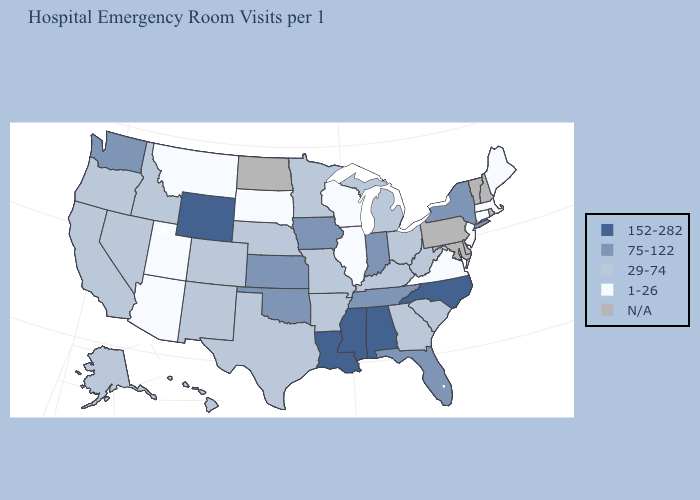Name the states that have a value in the range 1-26?
Quick response, please. Arizona, Connecticut, Illinois, Maine, Massachusetts, Montana, New Jersey, South Dakota, Utah, Virginia, Wisconsin. Does Indiana have the lowest value in the USA?
Answer briefly. No. Name the states that have a value in the range 152-282?
Give a very brief answer. Alabama, Louisiana, Mississippi, North Carolina, Wyoming. Name the states that have a value in the range 29-74?
Write a very short answer. Alaska, Arkansas, California, Colorado, Georgia, Hawaii, Idaho, Kentucky, Michigan, Minnesota, Missouri, Nebraska, Nevada, New Mexico, Ohio, Oregon, South Carolina, Texas, West Virginia. Name the states that have a value in the range 29-74?
Keep it brief. Alaska, Arkansas, California, Colorado, Georgia, Hawaii, Idaho, Kentucky, Michigan, Minnesota, Missouri, Nebraska, Nevada, New Mexico, Ohio, Oregon, South Carolina, Texas, West Virginia. Name the states that have a value in the range N/A?
Quick response, please. Delaware, Maryland, New Hampshire, North Dakota, Pennsylvania, Rhode Island, Vermont. Which states have the lowest value in the South?
Give a very brief answer. Virginia. What is the value of Alabama?
Keep it brief. 152-282. Among the states that border Georgia , does Alabama have the highest value?
Be succinct. Yes. Does South Dakota have the lowest value in the MidWest?
Keep it brief. Yes. Among the states that border Maryland , does Virginia have the lowest value?
Answer briefly. Yes. Does Kansas have the highest value in the MidWest?
Give a very brief answer. Yes. Does Kansas have the lowest value in the MidWest?
Concise answer only. No. 